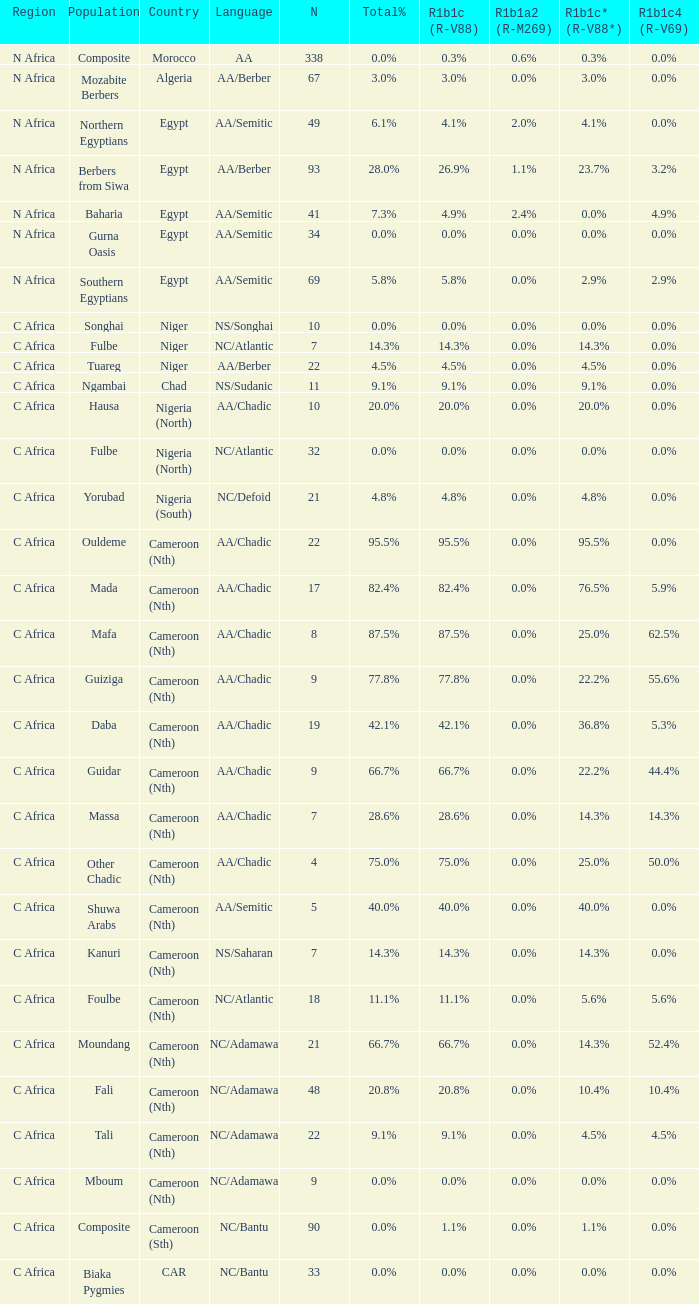6% r1b1a2 (r-m269)? 1.0. 